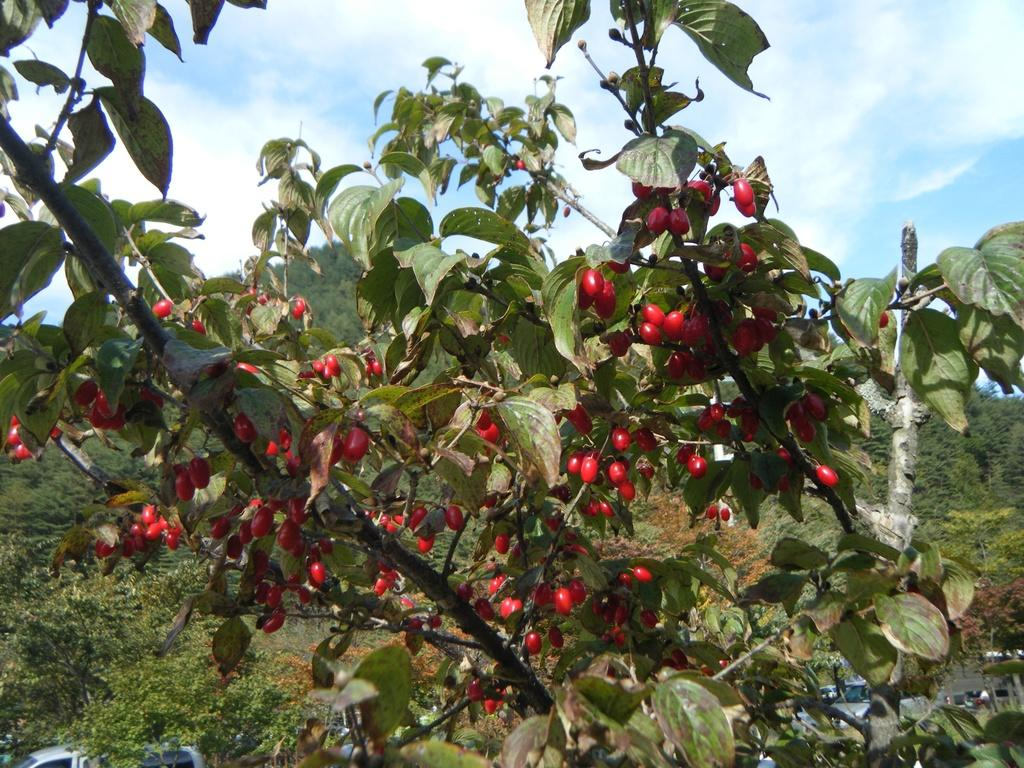What can be seen in the sky in the image? Clouds are visible in the image. What type of vegetation is present in the image? Trees and plants are present in the image. What is the ground covered with in the image? Grass is visible in the image. What type of objects can be seen in the image? Vehicles are in the image. What type of food is present in the image? Fruits are present in the image. How is the chain being used in the image? There is no chain present in the image. What type of brake is visible on the vehicles in the image? There is no brake visible on the vehicles in the image. 